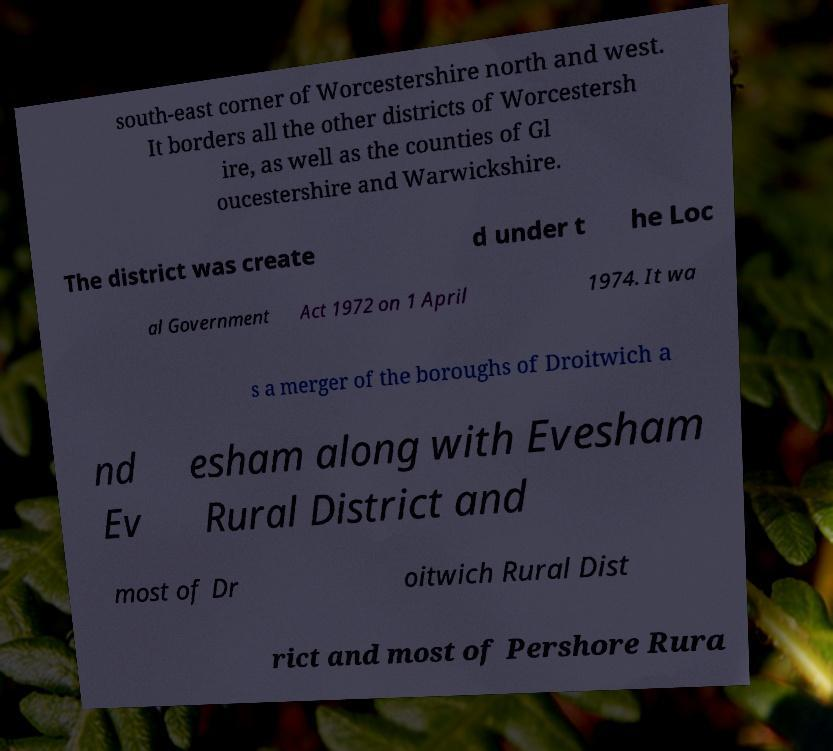Please identify and transcribe the text found in this image. south-east corner of Worcestershire north and west. It borders all the other districts of Worcestersh ire, as well as the counties of Gl oucestershire and Warwickshire. The district was create d under t he Loc al Government Act 1972 on 1 April 1974. It wa s a merger of the boroughs of Droitwich a nd Ev esham along with Evesham Rural District and most of Dr oitwich Rural Dist rict and most of Pershore Rura 